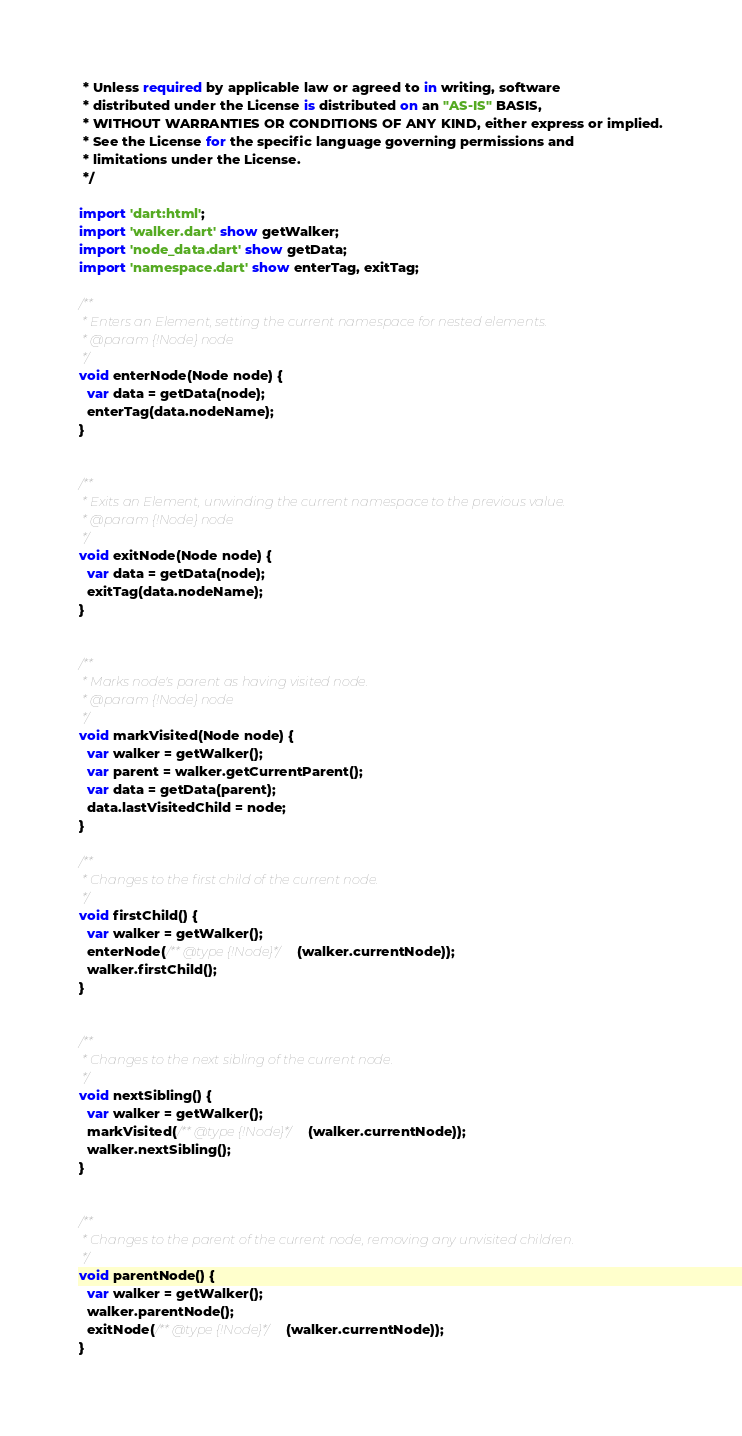Convert code to text. <code><loc_0><loc_0><loc_500><loc_500><_Dart_> * Unless required by applicable law or agreed to in writing, software
 * distributed under the License is distributed on an "AS-IS" BASIS,
 * WITHOUT WARRANTIES OR CONDITIONS OF ANY KIND, either express or implied.
 * See the License for the specific language governing permissions and
 * limitations under the License.
 */

import 'dart:html';
import 'walker.dart' show getWalker;
import 'node_data.dart' show getData;
import 'namespace.dart' show enterTag, exitTag;

/**
 * Enters an Element, setting the current namespace for nested elements.
 * @param {!Node} node
 */
void enterNode(Node node) {
  var data = getData(node);
  enterTag(data.nodeName);
}


/**
 * Exits an Element, unwinding the current namespace to the previous value.
 * @param {!Node} node
 */
void exitNode(Node node) {
  var data = getData(node);
  exitTag(data.nodeName);
}


/**
 * Marks node's parent as having visited node.
 * @param {!Node} node
 */
void markVisited(Node node) {
  var walker = getWalker();
  var parent = walker.getCurrentParent();
  var data = getData(parent);
  data.lastVisitedChild = node;
}

/**
 * Changes to the first child of the current node.
 */
void firstChild() {
  var walker = getWalker();
  enterNode(/** @type {!Node}*/(walker.currentNode));
  walker.firstChild();
}


/**
 * Changes to the next sibling of the current node.
 */
void nextSibling() {
  var walker = getWalker();
  markVisited(/** @type {!Node}*/(walker.currentNode));
  walker.nextSibling();
}


/**
 * Changes to the parent of the current node, removing any unvisited children.
 */
void parentNode() {
  var walker = getWalker();
  walker.parentNode();
  exitNode(/** @type {!Node}*/(walker.currentNode));
}
</code> 